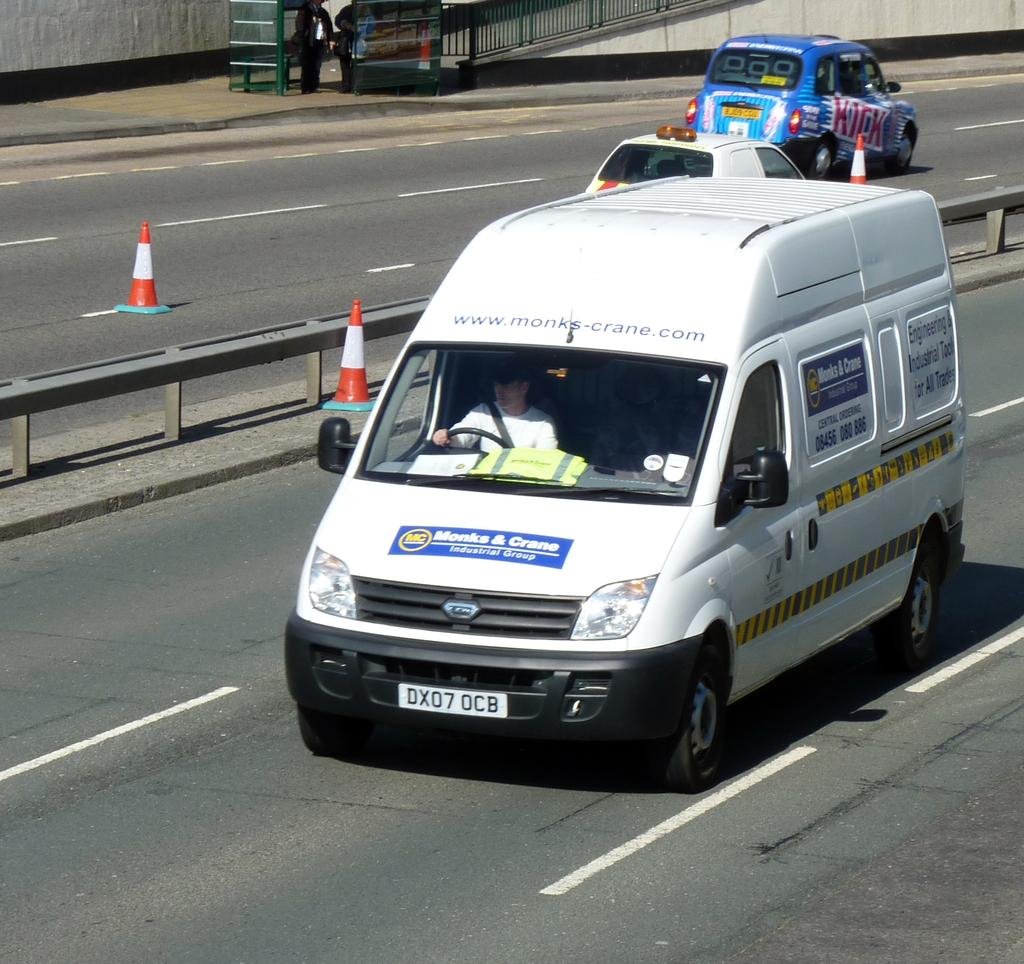<image>
Give a short and clear explanation of the subsequent image. a white van on a highway from Monks & Crane 